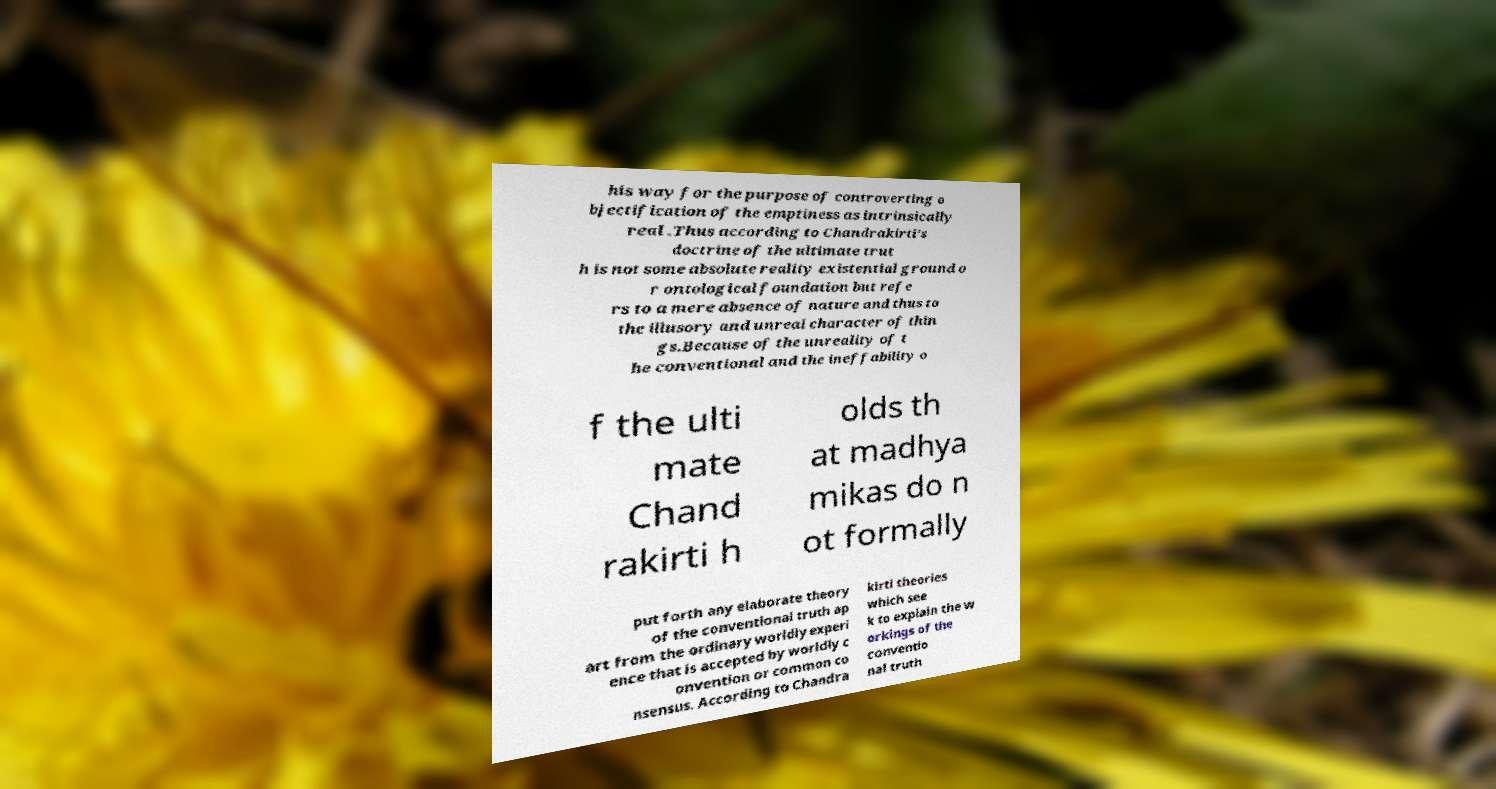Could you assist in decoding the text presented in this image and type it out clearly? his way for the purpose of controverting o bjectification of the emptiness as intrinsically real .Thus according to Chandrakirti's doctrine of the ultimate trut h is not some absolute reality existential ground o r ontological foundation but refe rs to a mere absence of nature and thus to the illusory and unreal character of thin gs.Because of the unreality of t he conventional and the ineffability o f the ulti mate Chand rakirti h olds th at madhya mikas do n ot formally put forth any elaborate theory of the conventional truth ap art from the ordinary worldly experi ence that is accepted by worldly c onvention or common co nsensus. According to Chandra kirti theories which see k to explain the w orkings of the conventio nal truth 